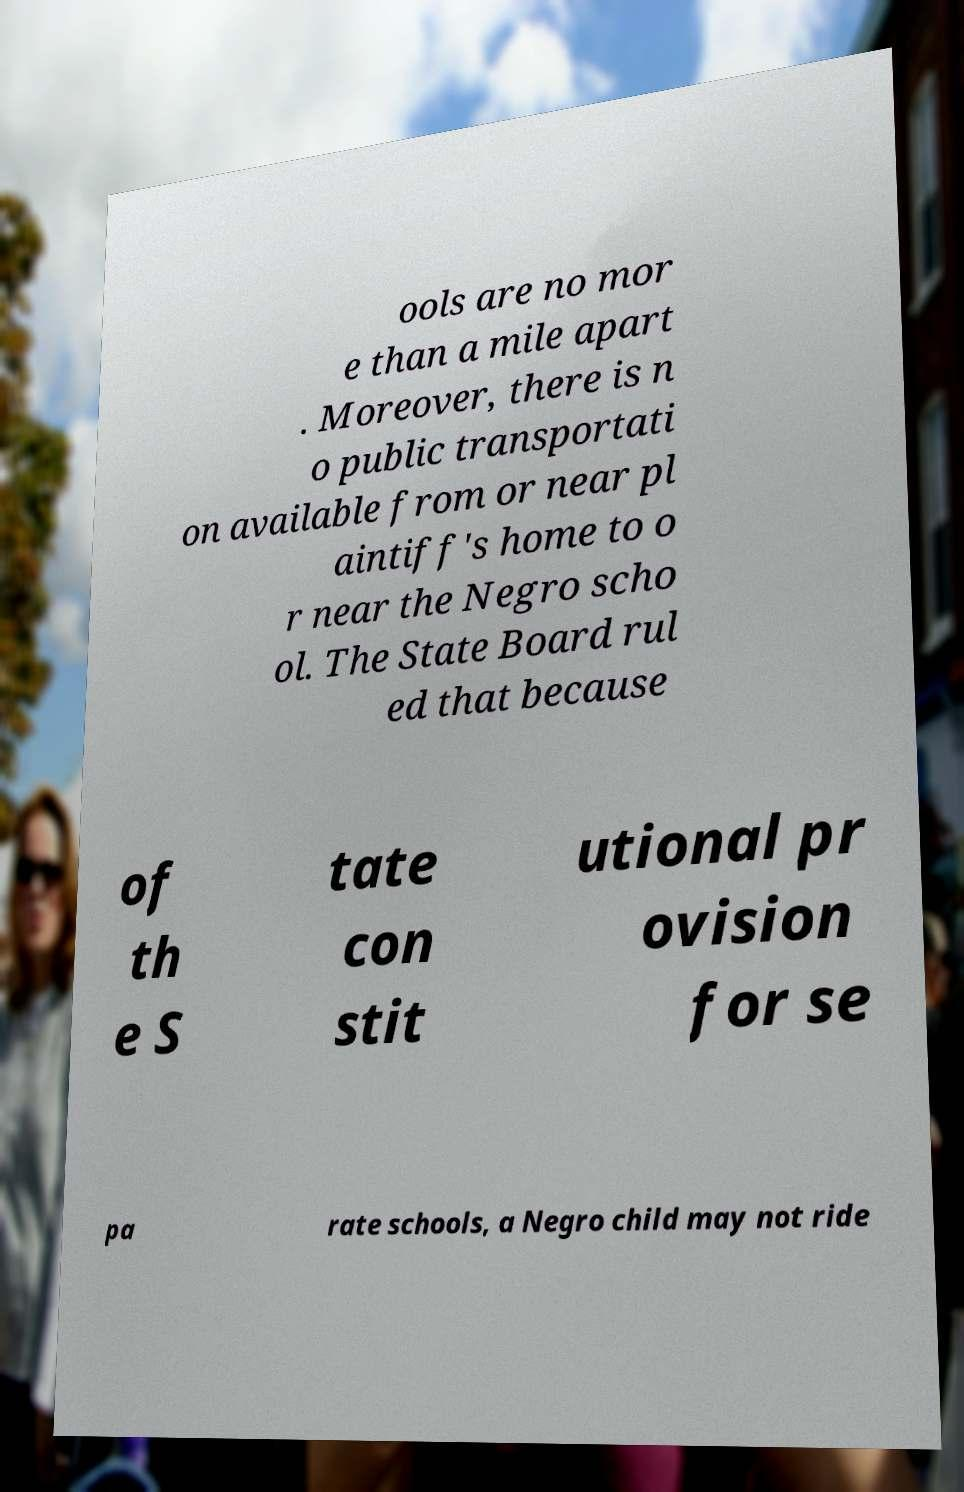For documentation purposes, I need the text within this image transcribed. Could you provide that? ools are no mor e than a mile apart . Moreover, there is n o public transportati on available from or near pl aintiff's home to o r near the Negro scho ol. The State Board rul ed that because of th e S tate con stit utional pr ovision for se pa rate schools, a Negro child may not ride 